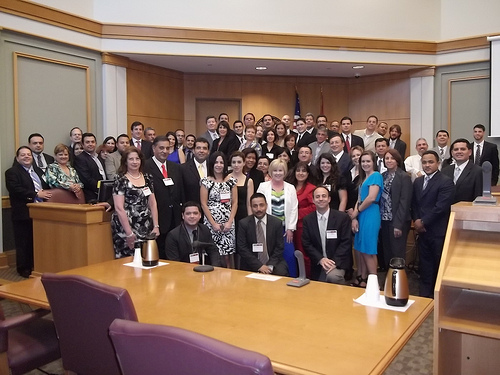<image>
Can you confirm if the person one is in front of the person two? Yes. The person one is positioned in front of the person two, appearing closer to the camera viewpoint. 